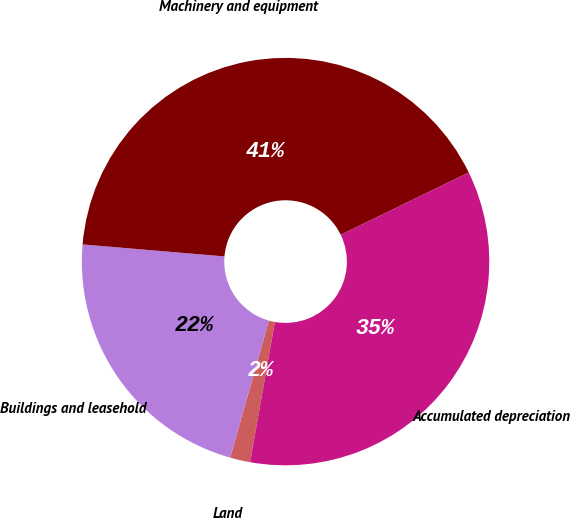Convert chart. <chart><loc_0><loc_0><loc_500><loc_500><pie_chart><fcel>Land<fcel>Buildings and leasehold<fcel>Machinery and equipment<fcel>Accumulated depreciation<nl><fcel>1.6%<fcel>21.96%<fcel>41.45%<fcel>34.99%<nl></chart> 